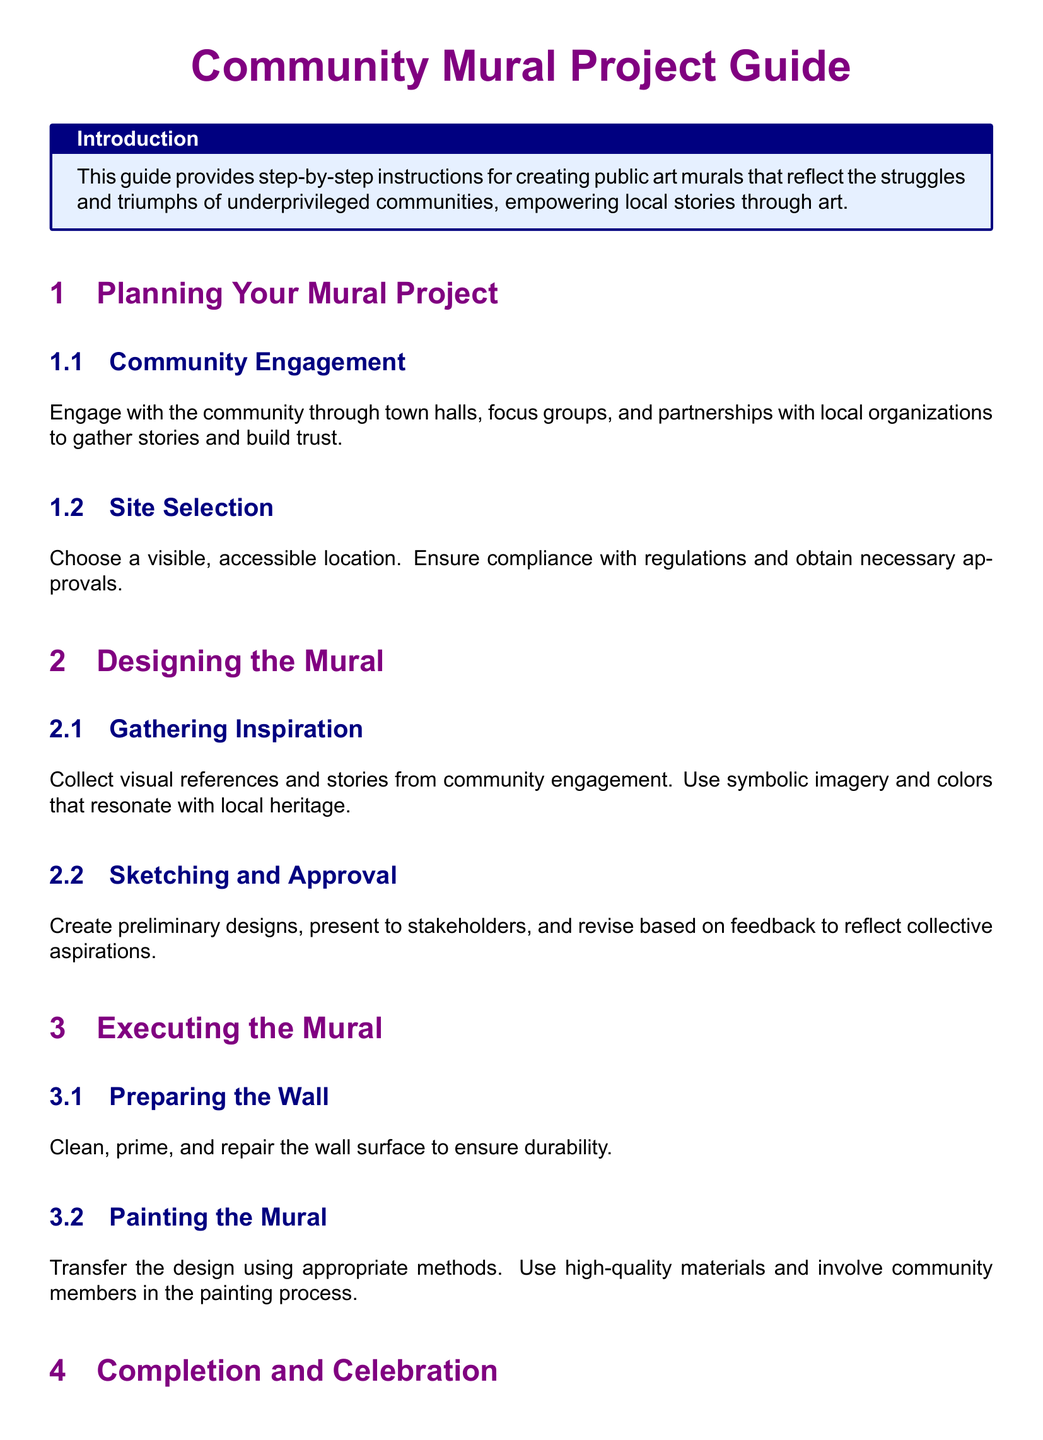What is the purpose of the Community Mural Project Guide? The purpose is to provide step-by-step instructions for creating public art murals that reflect the struggles and triumphs of underprivileged communities, empowering local stories through art.
Answer: Empowering local stories through art What section covers engaging with the community? The section that covers engaging with the community is under Planning Your Mural Project.
Answer: Planning Your Mural Project How many subsections are there under Designing the Mural? There are two subsections: Gathering Inspiration and Sketching and Approval.
Answer: Two What is the first step in executing the mural? The first step is Preparing the Wall.
Answer: Preparing the Wall What should be applied to protect the mural from vandalism? Protective varnish should be applied.
Answer: Protective varnish What is required prior to painting the mural? Cleaning, priming, and repairing the wall surface is required.
Answer: Cleaning, priming, and repairing How does creating community murals benefit public spaces? It beautifies public spaces and strengthens community bonds.
Answer: Beautifies public spaces and strengthens community bonds What is the last task mentioned in the guide? The last task mentioned is organizing a celebratory event to unveil the mural.
Answer: Organizing a celebratory event What does the guide suggest involving community members in? The guide suggests involving community members in the painting process.
Answer: The painting process 